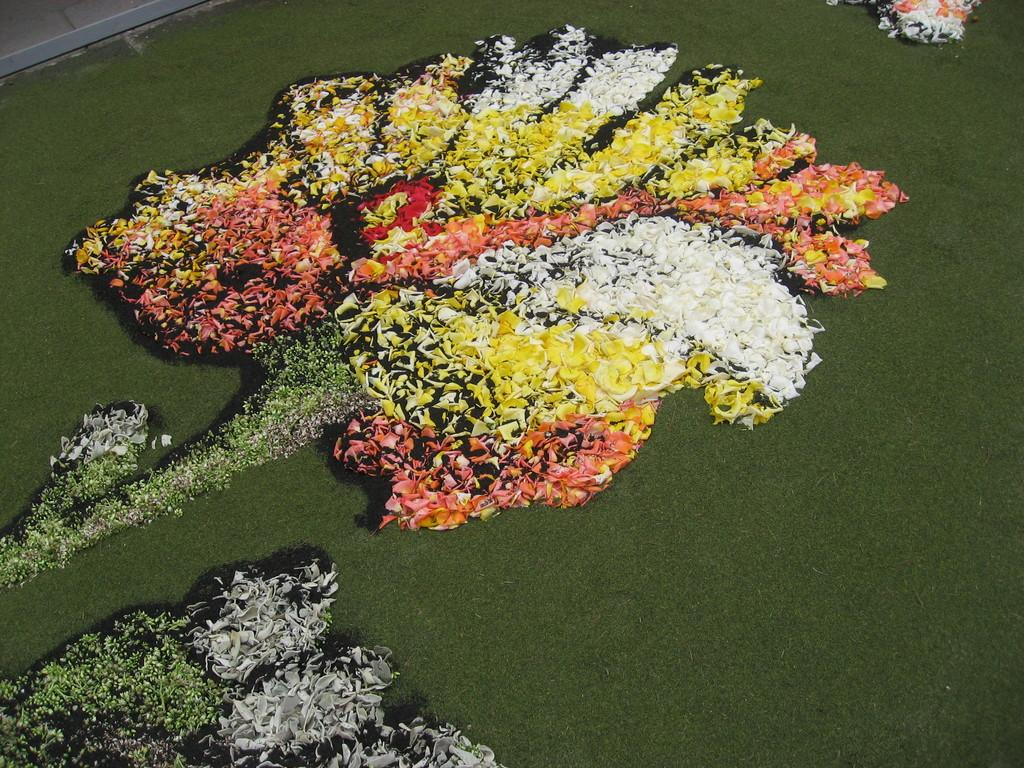What is the color of the mat in the image? The mat in the image is green. What type of decoration is on the mat? There is a flower shaped decoration on the mat. What colors are present in the flower petals? The flower petals have yellow, white, orange, and green colors. What type of polish is used on the flower petals in the image? There is no mention of polish in the image, and the flower petals are a part of a decoration, not a real flower. 